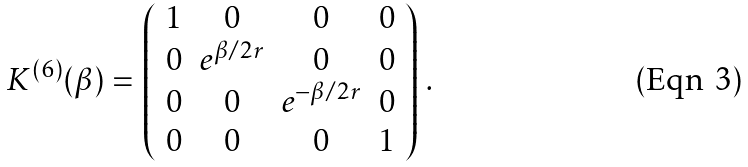Convert formula to latex. <formula><loc_0><loc_0><loc_500><loc_500>K ^ { ( 6 ) } ( \beta ) = \left ( \begin{array} { c c c c } 1 & 0 & 0 & 0 \\ 0 & e ^ { \beta / 2 r } & 0 & 0 \\ 0 & 0 & e ^ { - \beta / 2 r } & 0 \\ 0 & 0 & 0 & 1 \\ \end{array} \right ) \, .</formula> 